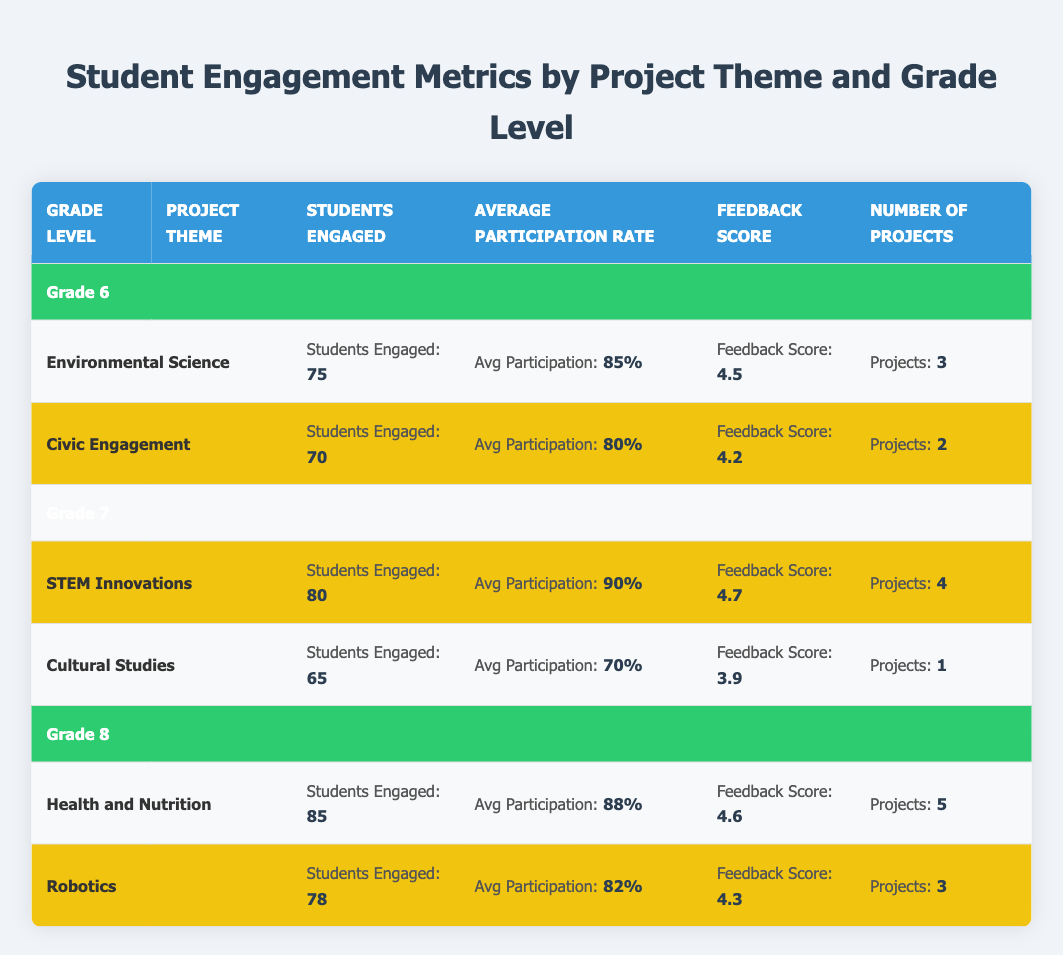What is the average feedback score for Grade 6 projects? The feedback scores for Grade 6 projects are 4.5 for Environmental Science and 4.2 for Civic Engagement. To find the average, we add both scores: 4.5 + 4.2 = 8.7. Then we divide by the number of projects (2): 8.7 / 2 = 4.35.
Answer: 4.35 Which project theme had the highest average participation rate in Grade 7? In Grade 7, STEM Innovations has an average participation rate of 90%, while Cultural Studies has an average participation rate of 70%. Therefore, STEM Innovations has the highest average participation rate.
Answer: STEM Innovations How many students were engaged in total across all project themes for Grade 8? For Grade 8, Health and Nutrition engaged 85 students and Robotics engaged 78 students. Adding these together gives: 85 + 78 = 163 students engaged in total across both themes.
Answer: 163 Is the feedback score for Civic Engagement higher than for Cultural Studies? The feedback score for Civic Engagement is 4.2, while the feedback score for Cultural Studies is 3.9. Since 4.2 is greater than 3.9, the feedback score for Civic Engagement is indeed higher.
Answer: Yes What is the difference in the number of projects between Grade 6 and Grade 8? In Grade 6, the total number of projects is 3 (Environmental Science) + 2 (Civic Engagement) = 5. In Grade 8, the total number of projects is 5 (Health and Nutrition) + 3 (Robotics) = 8. The difference is 8 - 5 = 3 projects.
Answer: 3 Which grade level had a higher average participation rate, Grade 6 or Grade 7? Grade 6 had an average participation rate of (85 + 80) / 2 = 82.5%, and Grade 7 had an average participation rate of 90%. Since 90% is greater than 82.5%, Grade 7 had a higher average participation rate.
Answer: Grade 7 What is the total number of students engaged in Environmental Science and Health and Nutrition combined? Environmental Science engaged 75 students and Health and Nutrition engaged 85 students. Adding these gives 75 + 85 = 160 students engaged in both themes.
Answer: 160 Is the average participation rate for Robotics higher than 80%? The average participation rate for Robotics is 82%. Since 82% is higher than 80%, the statement is true.
Answer: Yes Which project theme had the lowest number of engaged students? The lowest number of students engaged in Grade 7 is Cultural Studies with 65 students, compared to 70 in Civic Engagement, 75 in Environmental Science, and 78 in Robotics. Therefore, Cultural Studies is the theme with the lowest engagement.
Answer: Cultural Studies 